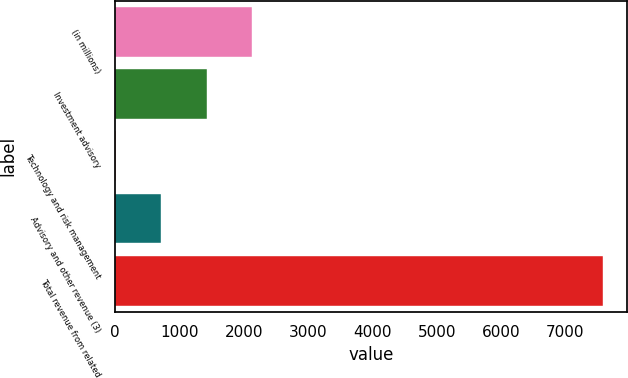<chart> <loc_0><loc_0><loc_500><loc_500><bar_chart><fcel>(in millions)<fcel>Investment advisory<fcel>Technology and risk management<fcel>Advisory and other revenue (3)<fcel>Total revenue from related<nl><fcel>2130.1<fcel>1422.4<fcel>7<fcel>714.7<fcel>7582.7<nl></chart> 